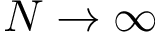Convert formula to latex. <formula><loc_0><loc_0><loc_500><loc_500>N \rightarrow \infty</formula> 